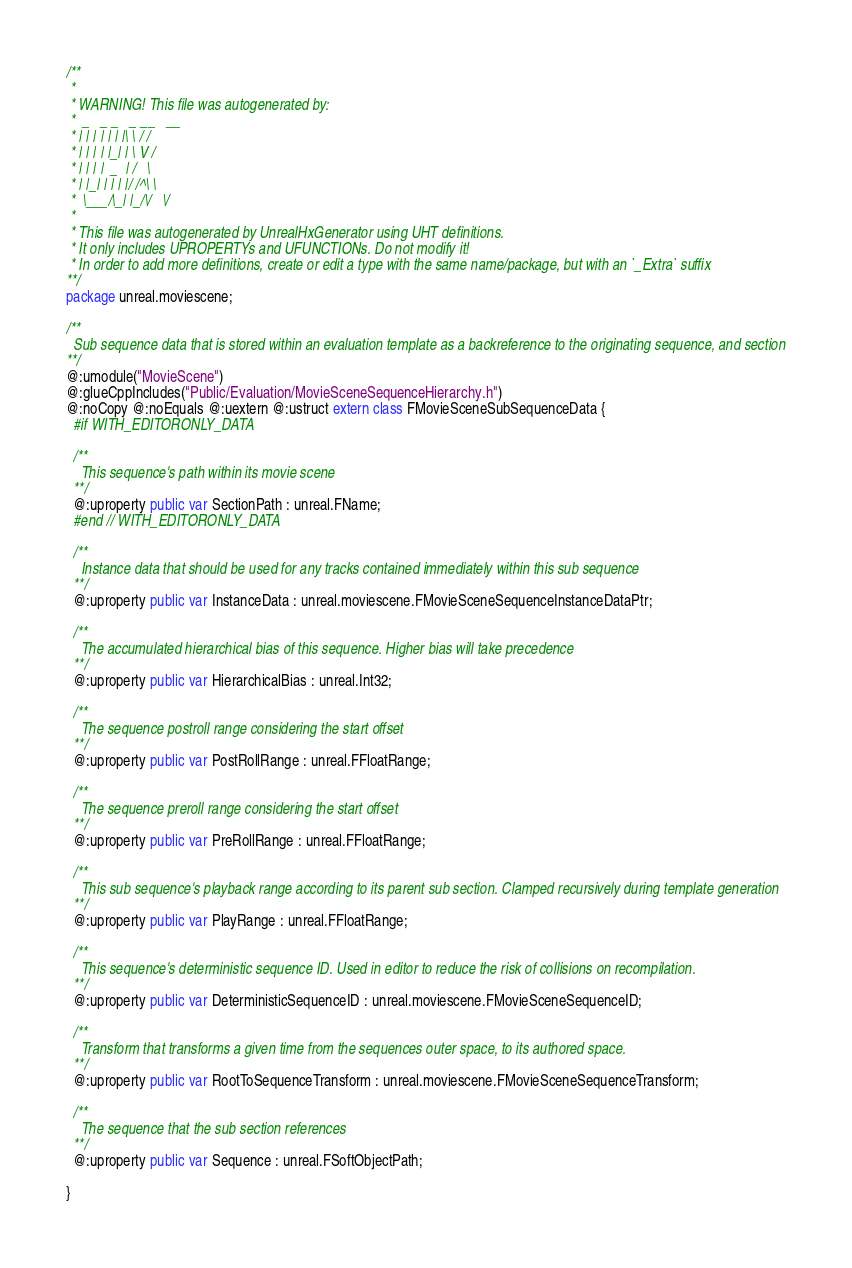<code> <loc_0><loc_0><loc_500><loc_500><_Haxe_>/**
 * 
 * WARNING! This file was autogenerated by: 
 *  _   _ _   _ __   __ 
 * | | | | | | |\ \ / / 
 * | | | | |_| | \ V /  
 * | | | |  _  | /   \  
 * | |_| | | | |/ /^\ \ 
 *  \___/\_| |_/\/   \/ 
 * 
 * This file was autogenerated by UnrealHxGenerator using UHT definitions.
 * It only includes UPROPERTYs and UFUNCTIONs. Do not modify it!
 * In order to add more definitions, create or edit a type with the same name/package, but with an `_Extra` suffix
**/
package unreal.moviescene;

/**
  Sub sequence data that is stored within an evaluation template as a backreference to the originating sequence, and section
**/
@:umodule("MovieScene")
@:glueCppIncludes("Public/Evaluation/MovieSceneSequenceHierarchy.h")
@:noCopy @:noEquals @:uextern @:ustruct extern class FMovieSceneSubSequenceData {
  #if WITH_EDITORONLY_DATA
  
  /**
    This sequence's path within its movie scene
  **/
  @:uproperty public var SectionPath : unreal.FName;
  #end // WITH_EDITORONLY_DATA
  
  /**
    Instance data that should be used for any tracks contained immediately within this sub sequence
  **/
  @:uproperty public var InstanceData : unreal.moviescene.FMovieSceneSequenceInstanceDataPtr;
  
  /**
    The accumulated hierarchical bias of this sequence. Higher bias will take precedence
  **/
  @:uproperty public var HierarchicalBias : unreal.Int32;
  
  /**
    The sequence postroll range considering the start offset
  **/
  @:uproperty public var PostRollRange : unreal.FFloatRange;
  
  /**
    The sequence preroll range considering the start offset
  **/
  @:uproperty public var PreRollRange : unreal.FFloatRange;
  
  /**
    This sub sequence's playback range according to its parent sub section. Clamped recursively during template generation
  **/
  @:uproperty public var PlayRange : unreal.FFloatRange;
  
  /**
    This sequence's deterministic sequence ID. Used in editor to reduce the risk of collisions on recompilation.
  **/
  @:uproperty public var DeterministicSequenceID : unreal.moviescene.FMovieSceneSequenceID;
  
  /**
    Transform that transforms a given time from the sequences outer space, to its authored space.
  **/
  @:uproperty public var RootToSequenceTransform : unreal.moviescene.FMovieSceneSequenceTransform;
  
  /**
    The sequence that the sub section references
  **/
  @:uproperty public var Sequence : unreal.FSoftObjectPath;
  
}
</code> 